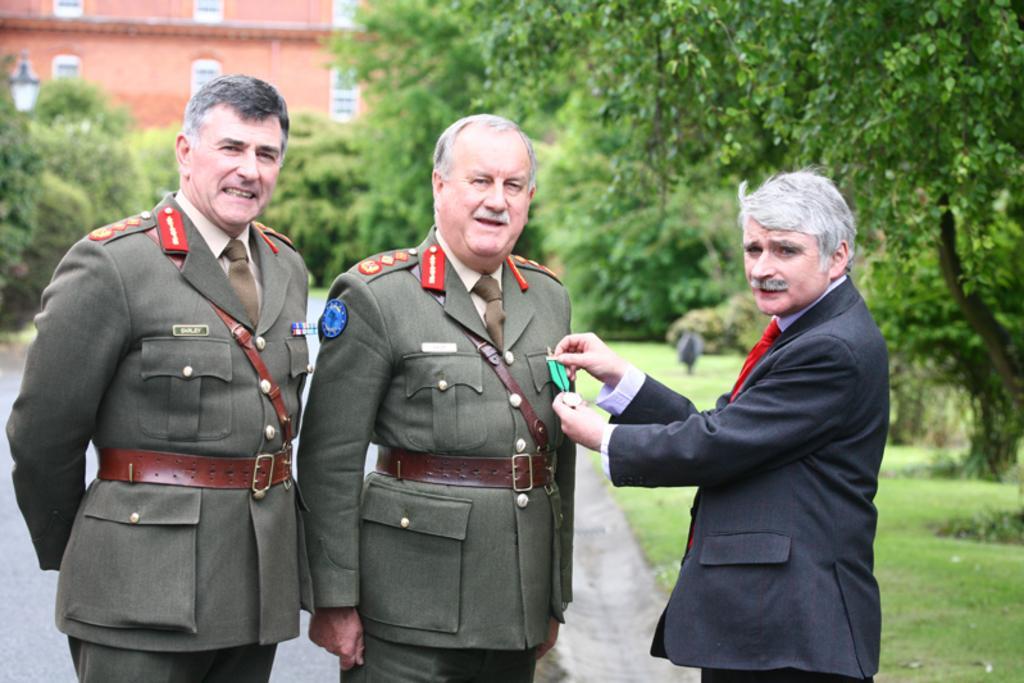Describe this image in one or two sentences. In this picture there are two military men wearing a green coat standing and giving a pose into camera. Beside there is a man wearing black color suit is honoring the medal to the military man. Behind there are some trees and brown color building. 